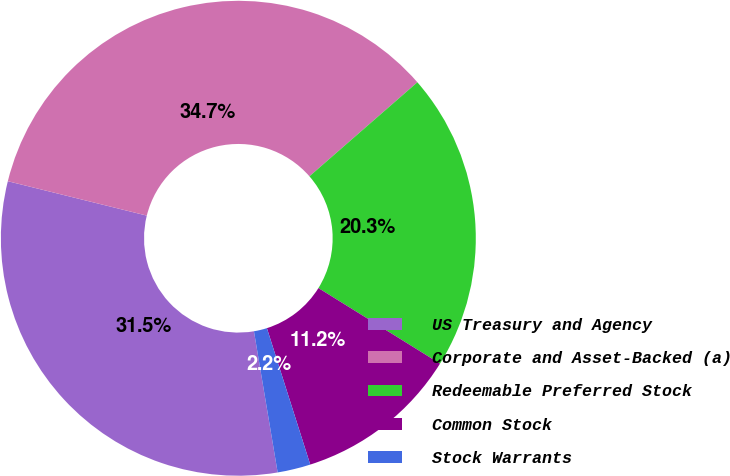Convert chart. <chart><loc_0><loc_0><loc_500><loc_500><pie_chart><fcel>US Treasury and Agency<fcel>Corporate and Asset-Backed (a)<fcel>Redeemable Preferred Stock<fcel>Common Stock<fcel>Stock Warrants<nl><fcel>31.51%<fcel>34.73%<fcel>20.26%<fcel>11.25%<fcel>2.25%<nl></chart> 